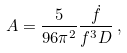<formula> <loc_0><loc_0><loc_500><loc_500>A = \frac { 5 } { 9 6 \pi ^ { 2 } } \frac { \dot { f } } { f ^ { 3 } D } \, ,</formula> 